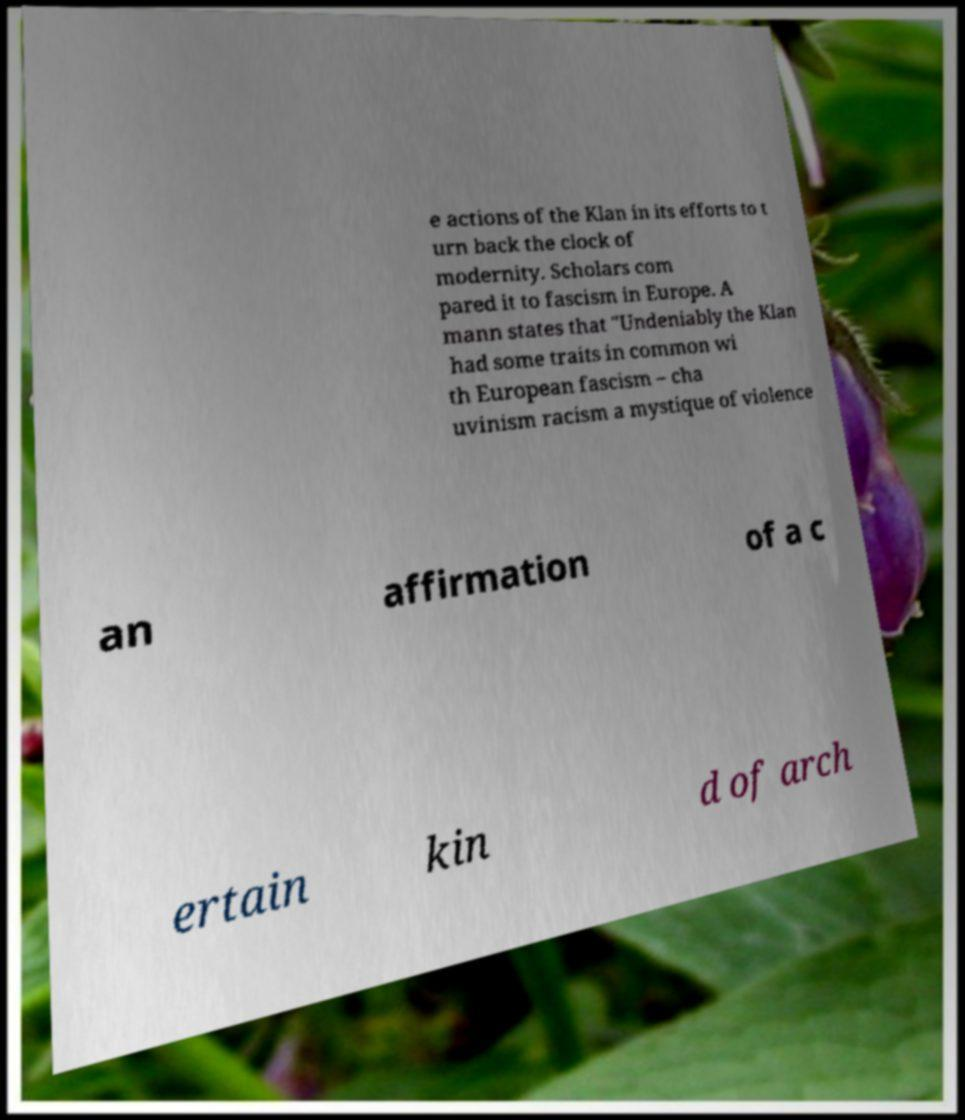What messages or text are displayed in this image? I need them in a readable, typed format. e actions of the Klan in its efforts to t urn back the clock of modernity. Scholars com pared it to fascism in Europe. A mann states that "Undeniably the Klan had some traits in common wi th European fascism – cha uvinism racism a mystique of violence an affirmation of a c ertain kin d of arch 